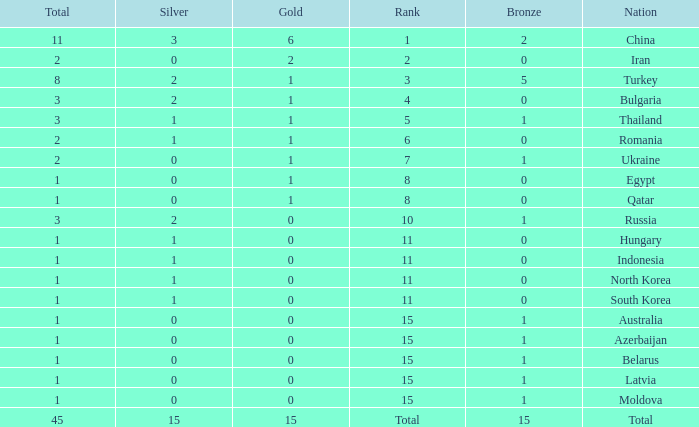Wha is the average number of bronze of hungary, which has less than 1 silver? None. 